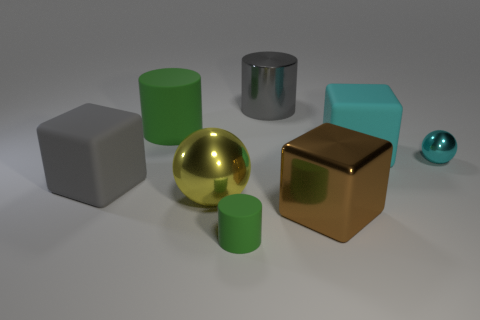How many objects are small spheres or tiny green matte blocks?
Your answer should be compact. 1. What material is the big object that is both left of the large yellow metallic ball and in front of the cyan metallic object?
Your answer should be compact. Rubber. Is the size of the yellow shiny ball the same as the gray rubber block?
Make the answer very short. Yes. There is a cyan cube that is behind the green matte cylinder in front of the gray cube; what size is it?
Ensure brevity in your answer.  Large. How many big things are both in front of the large cyan block and on the left side of the tiny green matte cylinder?
Your answer should be very brief. 2. There is a gray object that is to the right of the cylinder in front of the big cyan rubber block; are there any gray objects that are in front of it?
Offer a terse response. Yes. There is a thing that is the same size as the cyan shiny ball; what shape is it?
Offer a terse response. Cylinder. Is there another small matte cylinder that has the same color as the small matte cylinder?
Provide a succinct answer. No. Is the big yellow thing the same shape as the cyan metallic thing?
Your answer should be compact. Yes. How many large objects are cyan metal spheres or cyan cubes?
Offer a terse response. 1. 